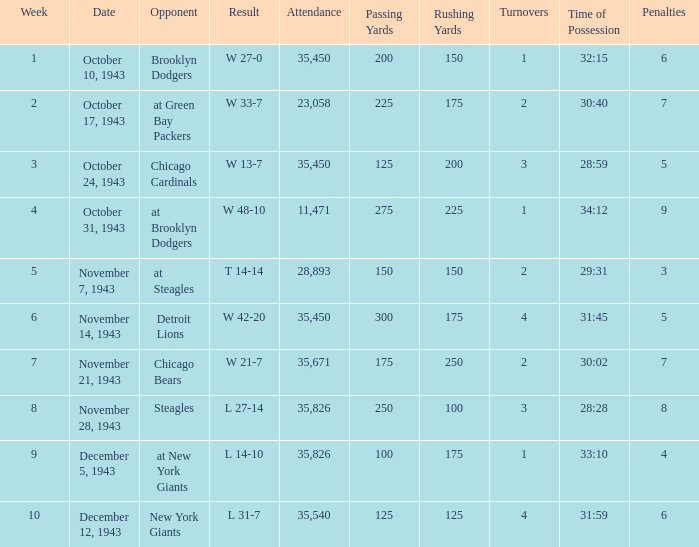What is the lowest attendance that has a week less than 4, and w 13-7 as the result? 35450.0. 